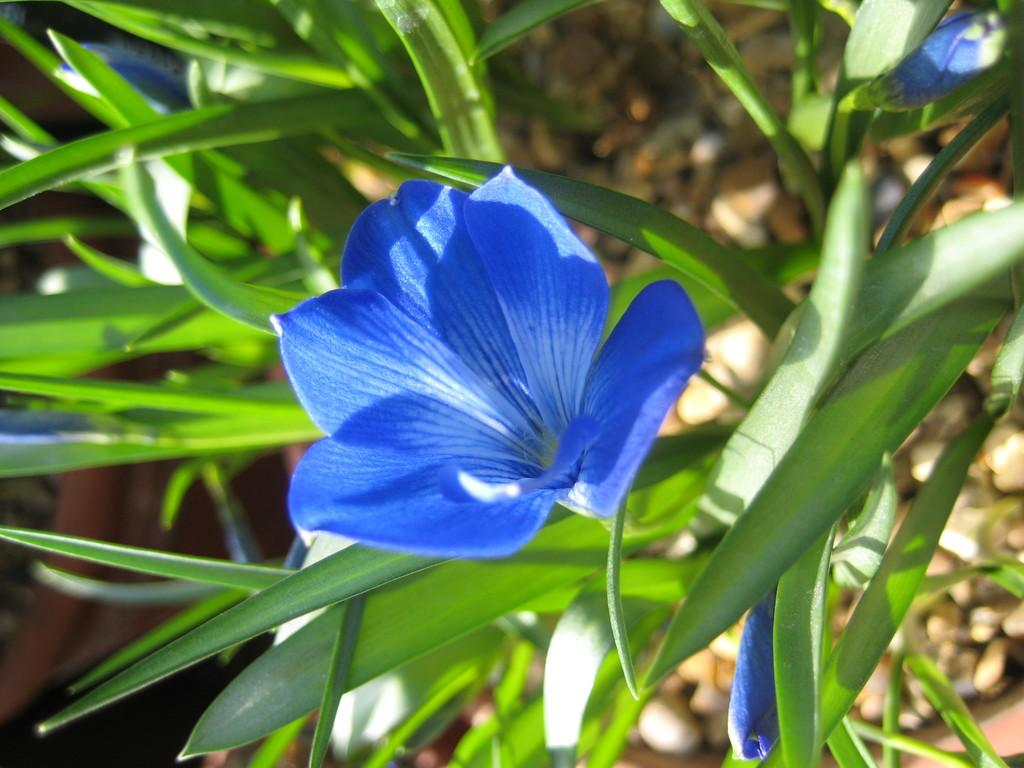What type of plant life is present in the image? There are flowers and leaves in the image. What can be seen in the background of the image? There are stones visible in the background of the image. Are there any other objects or features in the background of the image? Yes, there are some unspecified objects in the background of the image. Are there any bears visible in the image? No, there are no bears present in the image. What type of cave can be seen in the image? There is no cave present in the image. 